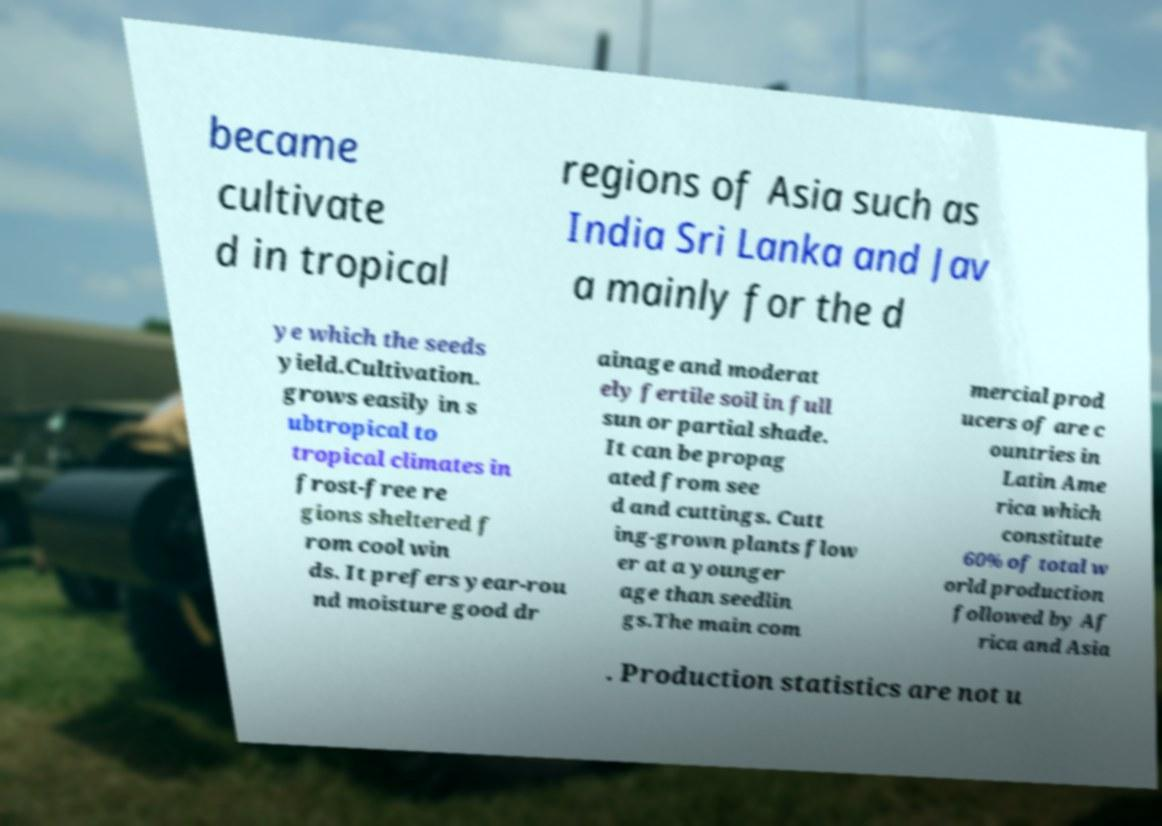Could you assist in decoding the text presented in this image and type it out clearly? became cultivate d in tropical regions of Asia such as India Sri Lanka and Jav a mainly for the d ye which the seeds yield.Cultivation. grows easily in s ubtropical to tropical climates in frost-free re gions sheltered f rom cool win ds. It prefers year-rou nd moisture good dr ainage and moderat ely fertile soil in full sun or partial shade. It can be propag ated from see d and cuttings. Cutt ing-grown plants flow er at a younger age than seedlin gs.The main com mercial prod ucers of are c ountries in Latin Ame rica which constitute 60% of total w orld production followed by Af rica and Asia . Production statistics are not u 